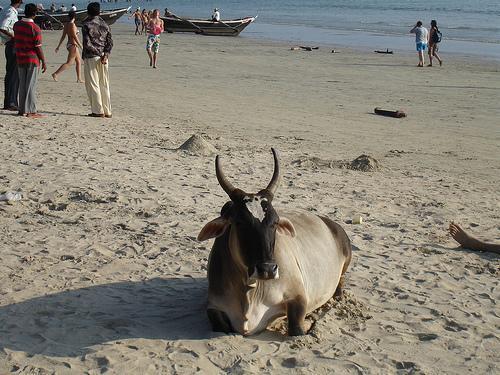How many goats are shown?
Give a very brief answer. 1. 